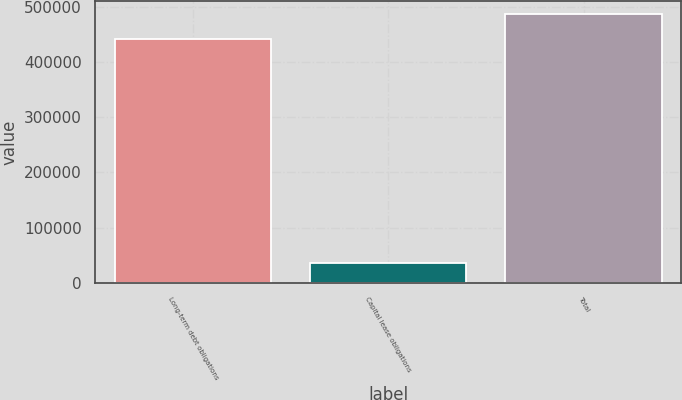Convert chart. <chart><loc_0><loc_0><loc_500><loc_500><bar_chart><fcel>Long-term debt obligations<fcel>Capital lease obligations<fcel>Total<nl><fcel>441964<fcel>36470<fcel>486160<nl></chart> 